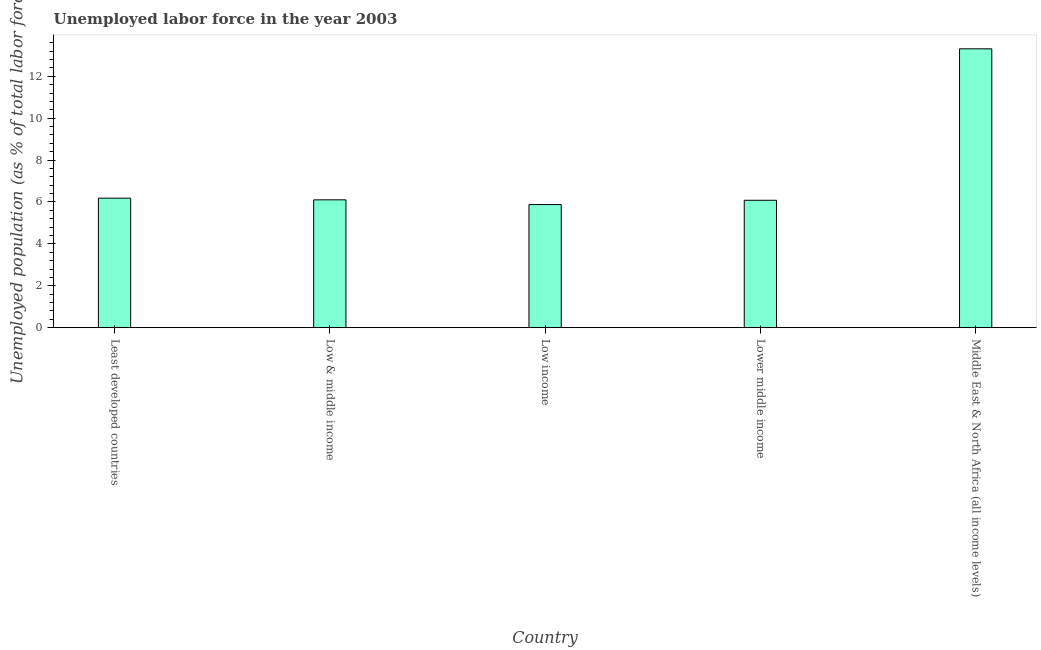Does the graph contain any zero values?
Keep it short and to the point. No. Does the graph contain grids?
Provide a succinct answer. No. What is the title of the graph?
Give a very brief answer. Unemployed labor force in the year 2003. What is the label or title of the X-axis?
Offer a very short reply. Country. What is the label or title of the Y-axis?
Make the answer very short. Unemployed population (as % of total labor force). What is the total unemployed population in Low & middle income?
Your answer should be compact. 6.1. Across all countries, what is the maximum total unemployed population?
Your answer should be compact. 13.31. Across all countries, what is the minimum total unemployed population?
Offer a very short reply. 5.88. In which country was the total unemployed population maximum?
Ensure brevity in your answer.  Middle East & North Africa (all income levels). What is the sum of the total unemployed population?
Offer a terse response. 37.56. What is the difference between the total unemployed population in Least developed countries and Lower middle income?
Offer a very short reply. 0.1. What is the average total unemployed population per country?
Your answer should be very brief. 7.51. What is the median total unemployed population?
Provide a short and direct response. 6.1. In how many countries, is the total unemployed population greater than 6 %?
Give a very brief answer. 4. What is the ratio of the total unemployed population in Low & middle income to that in Middle East & North Africa (all income levels)?
Your answer should be compact. 0.46. Is the total unemployed population in Low income less than that in Lower middle income?
Keep it short and to the point. Yes. What is the difference between the highest and the second highest total unemployed population?
Make the answer very short. 7.13. Is the sum of the total unemployed population in Low & middle income and Middle East & North Africa (all income levels) greater than the maximum total unemployed population across all countries?
Provide a succinct answer. Yes. What is the difference between the highest and the lowest total unemployed population?
Give a very brief answer. 7.44. Are all the bars in the graph horizontal?
Offer a very short reply. No. What is the difference between two consecutive major ticks on the Y-axis?
Your response must be concise. 2. What is the Unemployed population (as % of total labor force) in Least developed countries?
Your answer should be very brief. 6.18. What is the Unemployed population (as % of total labor force) of Low & middle income?
Your response must be concise. 6.1. What is the Unemployed population (as % of total labor force) of Low income?
Provide a short and direct response. 5.88. What is the Unemployed population (as % of total labor force) of Lower middle income?
Your answer should be very brief. 6.08. What is the Unemployed population (as % of total labor force) of Middle East & North Africa (all income levels)?
Offer a very short reply. 13.31. What is the difference between the Unemployed population (as % of total labor force) in Least developed countries and Low & middle income?
Keep it short and to the point. 0.08. What is the difference between the Unemployed population (as % of total labor force) in Least developed countries and Low income?
Give a very brief answer. 0.31. What is the difference between the Unemployed population (as % of total labor force) in Least developed countries and Lower middle income?
Make the answer very short. 0.1. What is the difference between the Unemployed population (as % of total labor force) in Least developed countries and Middle East & North Africa (all income levels)?
Provide a short and direct response. -7.13. What is the difference between the Unemployed population (as % of total labor force) in Low & middle income and Low income?
Your answer should be very brief. 0.23. What is the difference between the Unemployed population (as % of total labor force) in Low & middle income and Lower middle income?
Your response must be concise. 0.02. What is the difference between the Unemployed population (as % of total labor force) in Low & middle income and Middle East & North Africa (all income levels)?
Offer a very short reply. -7.21. What is the difference between the Unemployed population (as % of total labor force) in Low income and Lower middle income?
Provide a short and direct response. -0.2. What is the difference between the Unemployed population (as % of total labor force) in Low income and Middle East & North Africa (all income levels)?
Ensure brevity in your answer.  -7.44. What is the difference between the Unemployed population (as % of total labor force) in Lower middle income and Middle East & North Africa (all income levels)?
Make the answer very short. -7.23. What is the ratio of the Unemployed population (as % of total labor force) in Least developed countries to that in Low & middle income?
Your response must be concise. 1.01. What is the ratio of the Unemployed population (as % of total labor force) in Least developed countries to that in Low income?
Ensure brevity in your answer.  1.05. What is the ratio of the Unemployed population (as % of total labor force) in Least developed countries to that in Middle East & North Africa (all income levels)?
Offer a very short reply. 0.46. What is the ratio of the Unemployed population (as % of total labor force) in Low & middle income to that in Low income?
Provide a short and direct response. 1.04. What is the ratio of the Unemployed population (as % of total labor force) in Low & middle income to that in Lower middle income?
Your answer should be very brief. 1. What is the ratio of the Unemployed population (as % of total labor force) in Low & middle income to that in Middle East & North Africa (all income levels)?
Your response must be concise. 0.46. What is the ratio of the Unemployed population (as % of total labor force) in Low income to that in Middle East & North Africa (all income levels)?
Keep it short and to the point. 0.44. What is the ratio of the Unemployed population (as % of total labor force) in Lower middle income to that in Middle East & North Africa (all income levels)?
Keep it short and to the point. 0.46. 